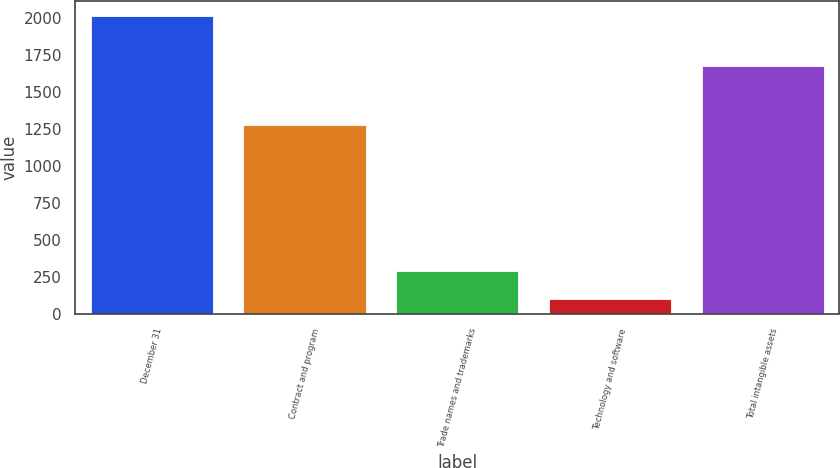Convert chart. <chart><loc_0><loc_0><loc_500><loc_500><bar_chart><fcel>December 31<fcel>Contract and program<fcel>Trade names and trademarks<fcel>Technology and software<fcel>Total intangible assets<nl><fcel>2016<fcel>1281<fcel>293.4<fcel>102<fcel>1676<nl></chart> 